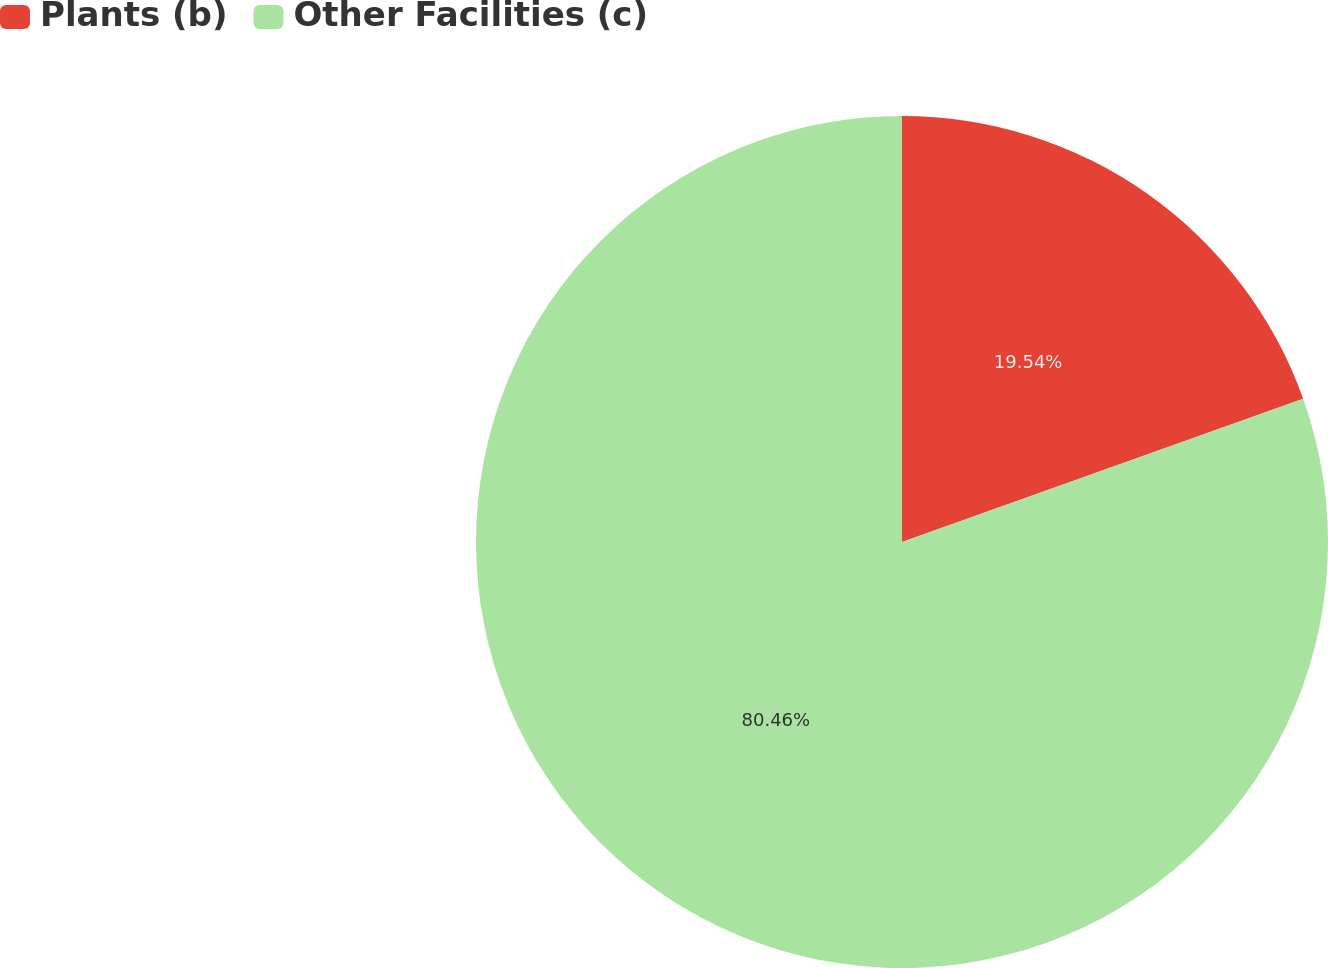<chart> <loc_0><loc_0><loc_500><loc_500><pie_chart><fcel>Plants (b)<fcel>Other Facilities (c)<nl><fcel>19.54%<fcel>80.46%<nl></chart> 